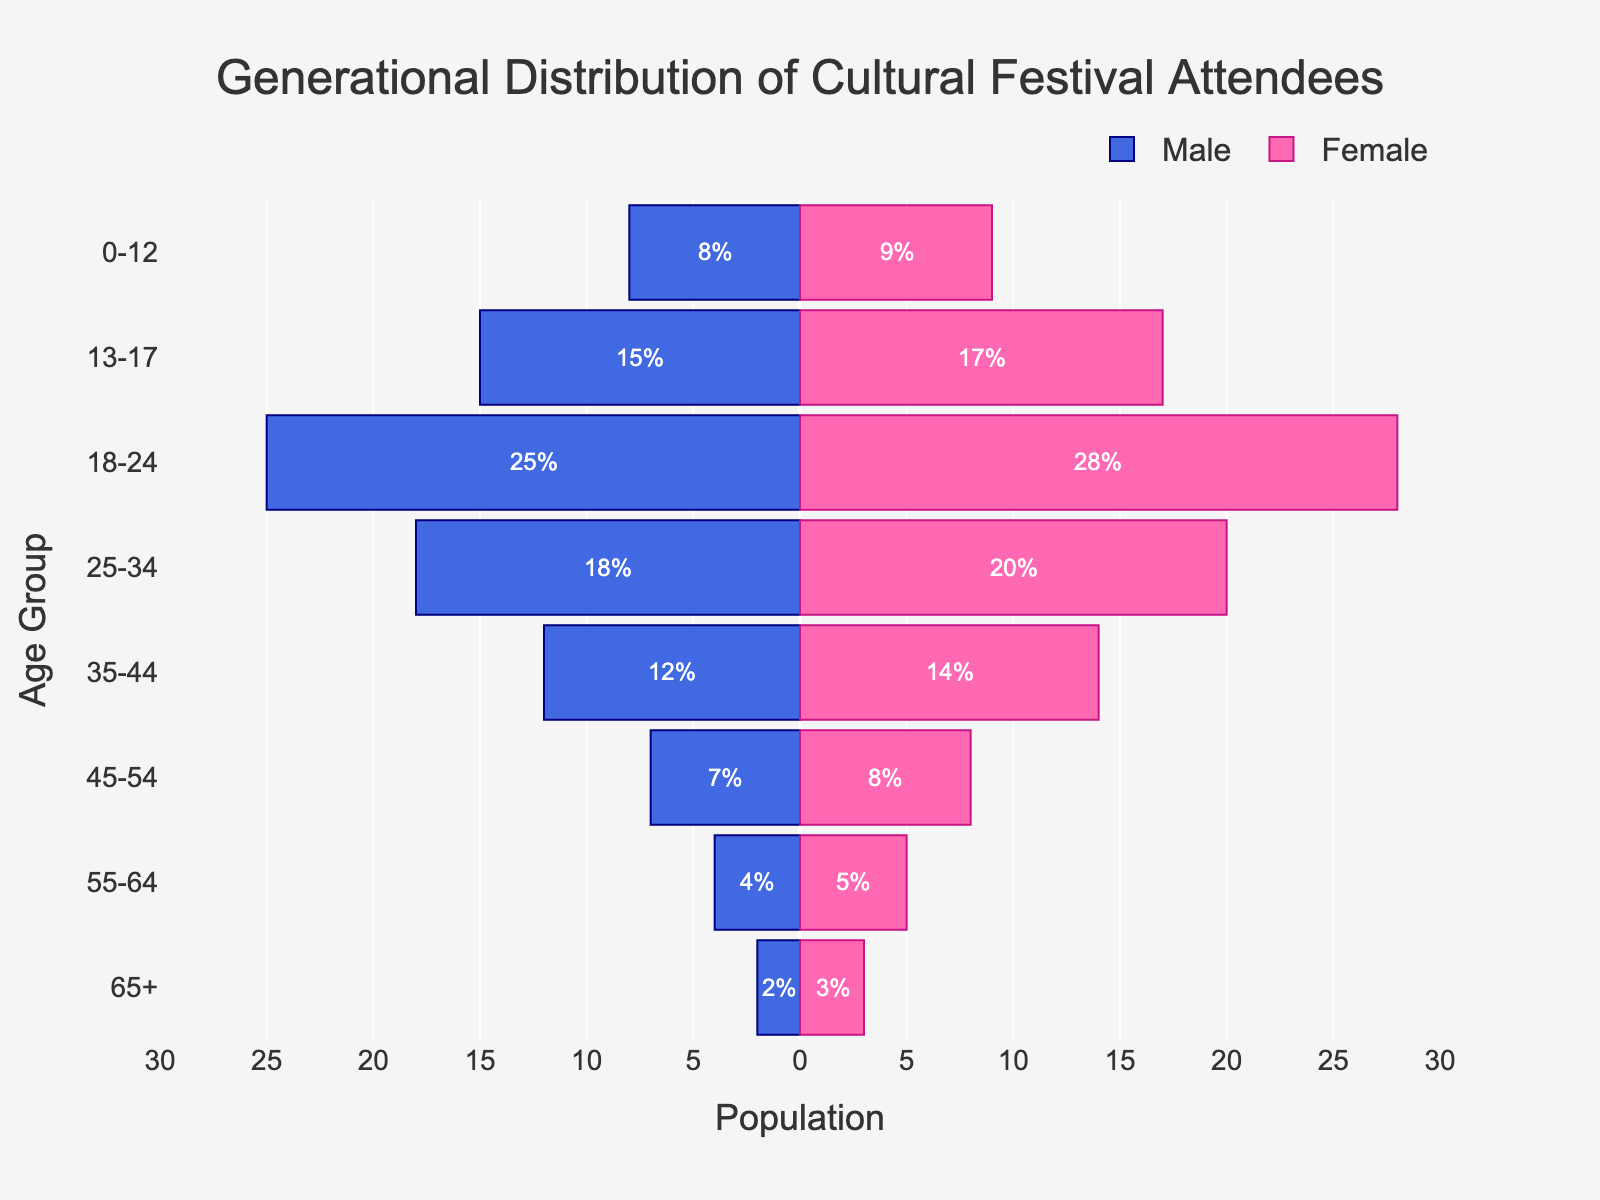what's the title of the figure? The title is written at the top center of the figure in a larger font. It describes the theme of the plot.
Answer: Generational Distribution of Cultural Festival Attendees what is the age group with the highest percentage of female attendees? Locate the pink bars representing females, identify the longest bar along the y-axis indicating age groups. The 18-24 age group has the longest pink bar.
Answer: 18-24 which age group has more male attendees than female attendees? Compare the lengths of blue (male) and pink (female) bars for each age group. Since none of the blue bars exceed the pink bars, no age group fits this criterion.
Answer: None what's the total percentage of attendees aged 25-34? Add the absolute values of male and female percentages for the 25-34 age group. Male: 18%, Female: 20%, Total: 18 + 20 = 38%.
Answer: 38% how many age groups have more than 10% male attendees? Identify the blue bars (male attendees) that extend beyond -10 on the x-axis. The age groups are 18-24, 25-34, and 35-44.
Answer: 3 what's the visual difference between male and female percentages for the 0-12 age group? Compare the lengths of blue and pink bars for the 0-12 age group. The female bar (9%) is slightly longer than the male bar (8%), difference: 9% - 8% = 1%.
Answer: 1% which gender has more attendees in the 35-44 age group and by how much? Compare the lengths of blue (12%) and pink (14%) bars for the 35-44 age group. The female bar (14%) is longer, difference: 14% - 12% = 2%.
Answer: Female, 2% what's the overall percentage of attendees younger than 18? Add the male and female percentages for the 0-12 and 13-17 age groups. (8 + 9) + (15 + 17) = 49%.
Answer: 49% which age group has the smallest difference between male and female attendees? Calculate the differences for each age group and find the age group with the smallest value. Differences: 1 (0-12), 2 (13-17), 3 (18-24), 2 (25-34), 2 (35-44), 1 (45-54), 1 (55-64), 1 (65+). The smallest differences are 1%.
Answer: 0-12, 45-54, 55-64, 65+ what trend do you observe in the attendee percentages as the age group gets older? Look at the lengths of the bars from younger to older age groups, notice the bars getting shorter for both males and females.
Answer: Percentages decrease as age increases 